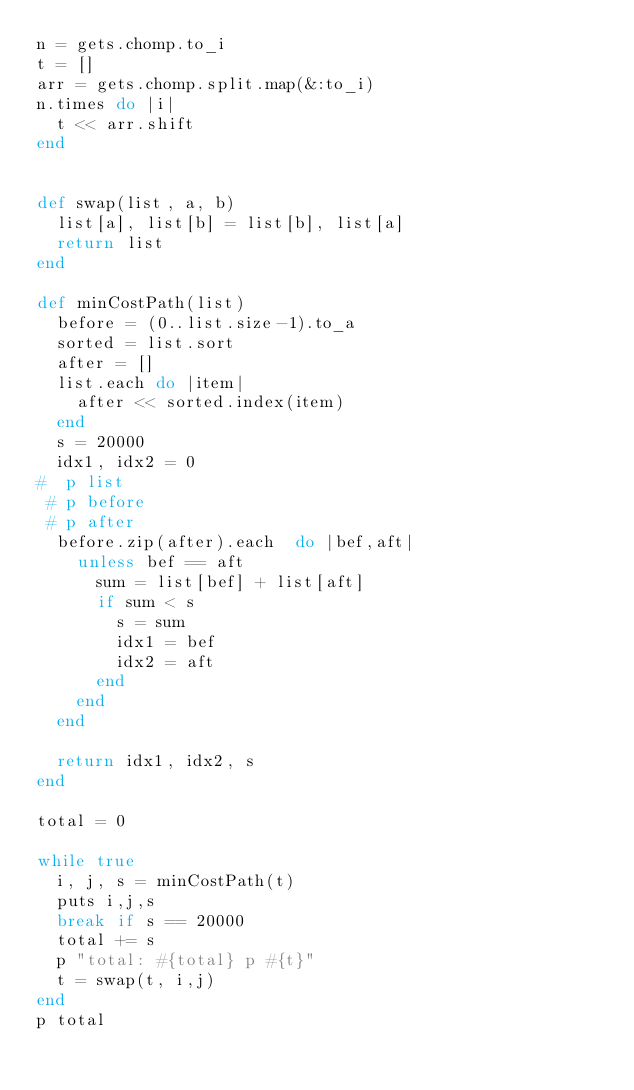<code> <loc_0><loc_0><loc_500><loc_500><_Ruby_>n = gets.chomp.to_i
t = []
arr = gets.chomp.split.map(&:to_i)
n.times do |i|
  t << arr.shift
end


def swap(list, a, b)
  list[a], list[b] = list[b], list[a]
  return list
end

def minCostPath(list)
  before = (0..list.size-1).to_a
  sorted = list.sort
  after = []
  list.each do |item|
    after << sorted.index(item) 
  end
  s = 20000
  idx1, idx2 = 0
#  p list
 # p before
 # p after
  before.zip(after).each  do |bef,aft|
    unless bef == aft
      sum = list[bef] + list[aft]  
      if sum < s
        s = sum
        idx1 = bef
        idx2 = aft
      end
    end
  end

  return idx1, idx2, s
end

total = 0

while true
  i, j, s = minCostPath(t)
  puts i,j,s
  break if s == 20000
  total += s
  p "total: #{total} p #{t}"
  t = swap(t, i,j)
end
p total</code> 